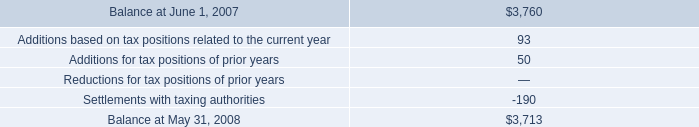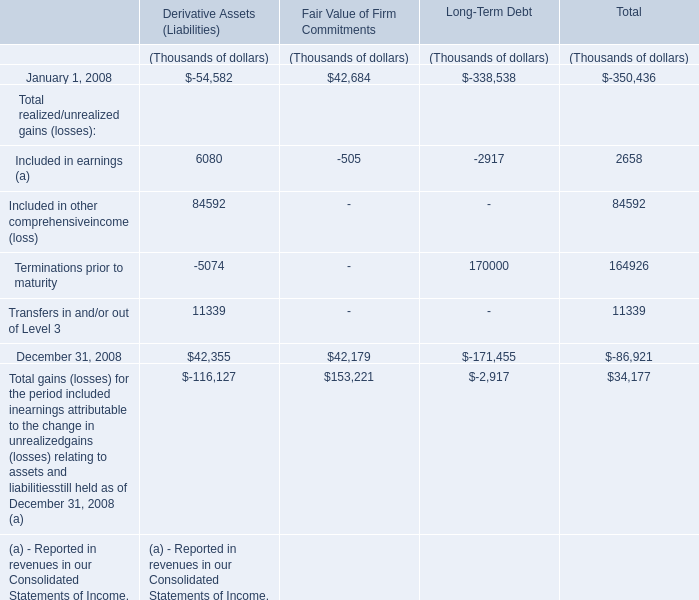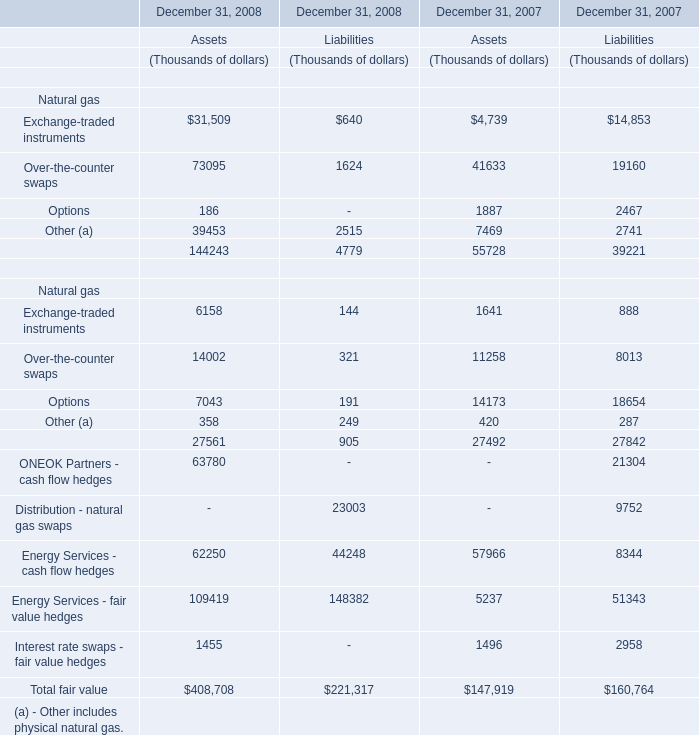In which section the sum of financial non-trading instruments has the highest value? (in Thousand) 
Computations: (144243 - 4779)
Answer: 139464.0. what is the highest total amount of financial non-trading instruments? (in Thousand) 
Computations: (144243 - 4779)
Answer: 139464.0. 